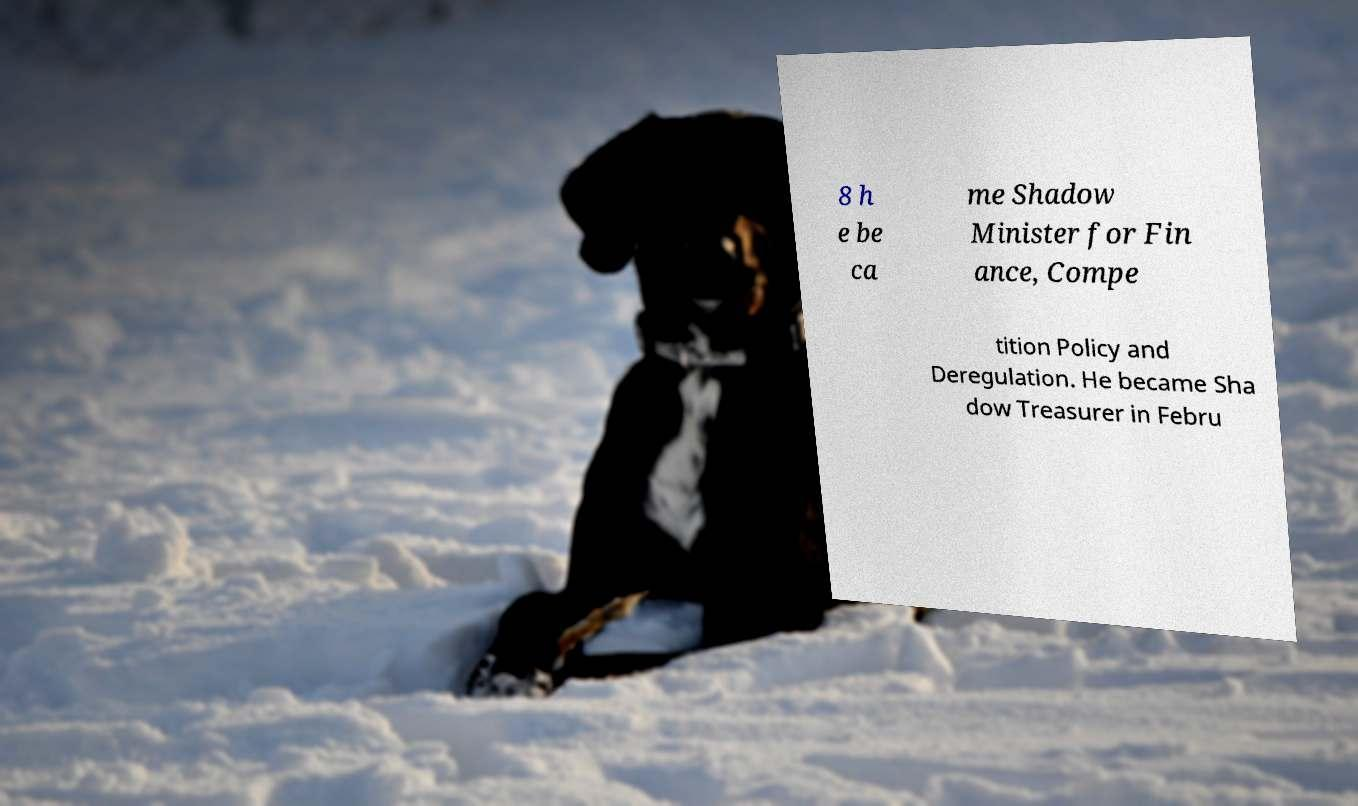Can you accurately transcribe the text from the provided image for me? 8 h e be ca me Shadow Minister for Fin ance, Compe tition Policy and Deregulation. He became Sha dow Treasurer in Febru 